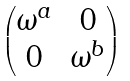<formula> <loc_0><loc_0><loc_500><loc_500>\begin{pmatrix} \omega ^ { a } & 0 \\ 0 & \omega ^ { b } \end{pmatrix}</formula> 